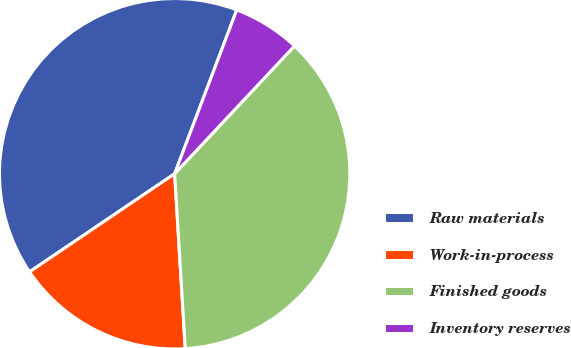<chart> <loc_0><loc_0><loc_500><loc_500><pie_chart><fcel>Raw materials<fcel>Work-in-process<fcel>Finished goods<fcel>Inventory reserves<nl><fcel>40.23%<fcel>16.5%<fcel>37.05%<fcel>6.22%<nl></chart> 